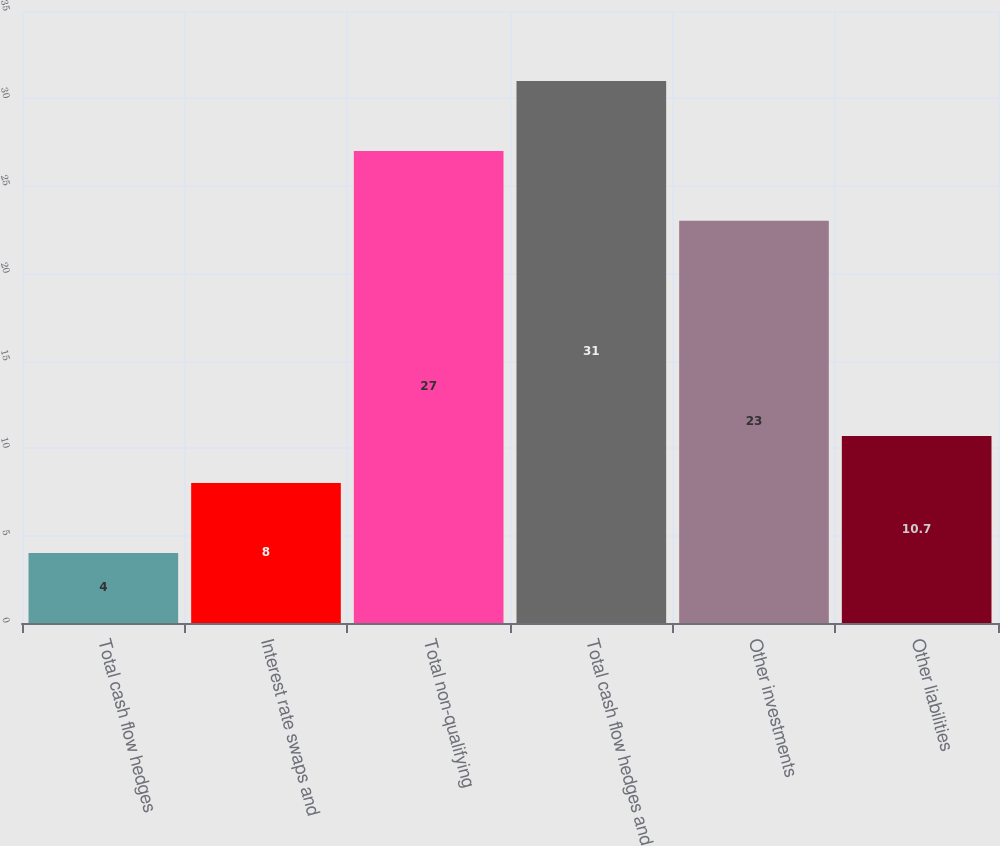Convert chart. <chart><loc_0><loc_0><loc_500><loc_500><bar_chart><fcel>Total cash flow hedges<fcel>Interest rate swaps and<fcel>Total non-qualifying<fcel>Total cash flow hedges and<fcel>Other investments<fcel>Other liabilities<nl><fcel>4<fcel>8<fcel>27<fcel>31<fcel>23<fcel>10.7<nl></chart> 